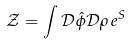<formula> <loc_0><loc_0><loc_500><loc_500>\mathcal { Z } = \int \mathcal { D } \hat { \phi } \mathcal { D } \rho \, e ^ { S }</formula> 